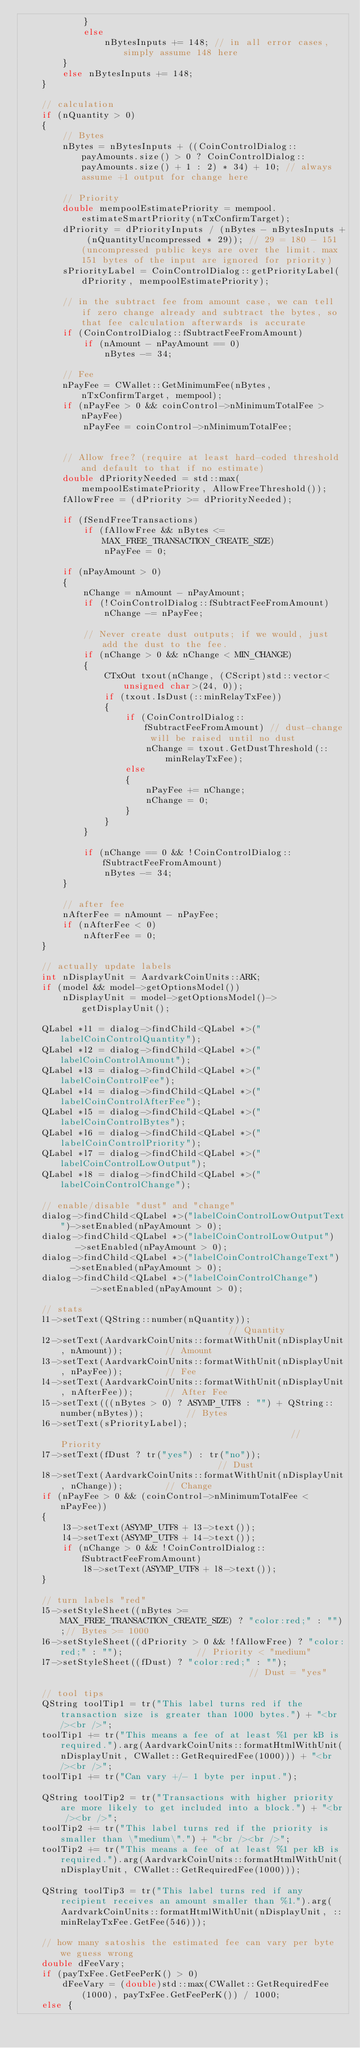<code> <loc_0><loc_0><loc_500><loc_500><_C++_>            }
            else
                nBytesInputs += 148; // in all error cases, simply assume 148 here
        }
        else nBytesInputs += 148;
    }

    // calculation
    if (nQuantity > 0)
    {
        // Bytes
        nBytes = nBytesInputs + ((CoinControlDialog::payAmounts.size() > 0 ? CoinControlDialog::payAmounts.size() + 1 : 2) * 34) + 10; // always assume +1 output for change here

        // Priority
        double mempoolEstimatePriority = mempool.estimateSmartPriority(nTxConfirmTarget);
        dPriority = dPriorityInputs / (nBytes - nBytesInputs + (nQuantityUncompressed * 29)); // 29 = 180 - 151 (uncompressed public keys are over the limit. max 151 bytes of the input are ignored for priority)
        sPriorityLabel = CoinControlDialog::getPriorityLabel(dPriority, mempoolEstimatePriority);

        // in the subtract fee from amount case, we can tell if zero change already and subtract the bytes, so that fee calculation afterwards is accurate
        if (CoinControlDialog::fSubtractFeeFromAmount)
            if (nAmount - nPayAmount == 0)
                nBytes -= 34;

        // Fee
        nPayFee = CWallet::GetMinimumFee(nBytes, nTxConfirmTarget, mempool);
        if (nPayFee > 0 && coinControl->nMinimumTotalFee > nPayFee)
            nPayFee = coinControl->nMinimumTotalFee;


        // Allow free? (require at least hard-coded threshold and default to that if no estimate)
        double dPriorityNeeded = std::max(mempoolEstimatePriority, AllowFreeThreshold());
        fAllowFree = (dPriority >= dPriorityNeeded);

        if (fSendFreeTransactions)
            if (fAllowFree && nBytes <= MAX_FREE_TRANSACTION_CREATE_SIZE)
                nPayFee = 0;

        if (nPayAmount > 0)
        {
            nChange = nAmount - nPayAmount;
            if (!CoinControlDialog::fSubtractFeeFromAmount)
                nChange -= nPayFee;

            // Never create dust outputs; if we would, just add the dust to the fee.
            if (nChange > 0 && nChange < MIN_CHANGE)
            {
                CTxOut txout(nChange, (CScript)std::vector<unsigned char>(24, 0));
                if (txout.IsDust(::minRelayTxFee))
                {
                    if (CoinControlDialog::fSubtractFeeFromAmount) // dust-change will be raised until no dust
                        nChange = txout.GetDustThreshold(::minRelayTxFee);
                    else
                    {
                        nPayFee += nChange;
                        nChange = 0;
                    }
                }
            }

            if (nChange == 0 && !CoinControlDialog::fSubtractFeeFromAmount)
                nBytes -= 34;
        }

        // after fee
        nAfterFee = nAmount - nPayFee;
        if (nAfterFee < 0)
            nAfterFee = 0;
    }

    // actually update labels
    int nDisplayUnit = AardvarkCoinUnits::ARK;
    if (model && model->getOptionsModel())
        nDisplayUnit = model->getOptionsModel()->getDisplayUnit();

    QLabel *l1 = dialog->findChild<QLabel *>("labelCoinControlQuantity");
    QLabel *l2 = dialog->findChild<QLabel *>("labelCoinControlAmount");
    QLabel *l3 = dialog->findChild<QLabel *>("labelCoinControlFee");
    QLabel *l4 = dialog->findChild<QLabel *>("labelCoinControlAfterFee");
    QLabel *l5 = dialog->findChild<QLabel *>("labelCoinControlBytes");
    QLabel *l6 = dialog->findChild<QLabel *>("labelCoinControlPriority");
    QLabel *l7 = dialog->findChild<QLabel *>("labelCoinControlLowOutput");
    QLabel *l8 = dialog->findChild<QLabel *>("labelCoinControlChange");

    // enable/disable "dust" and "change"
    dialog->findChild<QLabel *>("labelCoinControlLowOutputText")->setEnabled(nPayAmount > 0);
    dialog->findChild<QLabel *>("labelCoinControlLowOutput")    ->setEnabled(nPayAmount > 0);
    dialog->findChild<QLabel *>("labelCoinControlChangeText")   ->setEnabled(nPayAmount > 0);
    dialog->findChild<QLabel *>("labelCoinControlChange")       ->setEnabled(nPayAmount > 0);

    // stats
    l1->setText(QString::number(nQuantity));                                 // Quantity
    l2->setText(AardvarkCoinUnits::formatWithUnit(nDisplayUnit, nAmount));        // Amount
    l3->setText(AardvarkCoinUnits::formatWithUnit(nDisplayUnit, nPayFee));        // Fee
    l4->setText(AardvarkCoinUnits::formatWithUnit(nDisplayUnit, nAfterFee));      // After Fee
    l5->setText(((nBytes > 0) ? ASYMP_UTF8 : "") + QString::number(nBytes));        // Bytes
    l6->setText(sPriorityLabel);                                             // Priority
    l7->setText(fDust ? tr("yes") : tr("no"));                               // Dust
    l8->setText(AardvarkCoinUnits::formatWithUnit(nDisplayUnit, nChange));        // Change
    if (nPayFee > 0 && (coinControl->nMinimumTotalFee < nPayFee))
    {
        l3->setText(ASYMP_UTF8 + l3->text());
        l4->setText(ASYMP_UTF8 + l4->text());
        if (nChange > 0 && !CoinControlDialog::fSubtractFeeFromAmount)
            l8->setText(ASYMP_UTF8 + l8->text());
    }

    // turn labels "red"
    l5->setStyleSheet((nBytes >= MAX_FREE_TRANSACTION_CREATE_SIZE) ? "color:red;" : "");// Bytes >= 1000
    l6->setStyleSheet((dPriority > 0 && !fAllowFree) ? "color:red;" : "");              // Priority < "medium"
    l7->setStyleSheet((fDust) ? "color:red;" : "");                                     // Dust = "yes"

    // tool tips
    QString toolTip1 = tr("This label turns red if the transaction size is greater than 1000 bytes.") + "<br /><br />";
    toolTip1 += tr("This means a fee of at least %1 per kB is required.").arg(AardvarkCoinUnits::formatHtmlWithUnit(nDisplayUnit, CWallet::GetRequiredFee(1000))) + "<br /><br />";
    toolTip1 += tr("Can vary +/- 1 byte per input.");

    QString toolTip2 = tr("Transactions with higher priority are more likely to get included into a block.") + "<br /><br />";
    toolTip2 += tr("This label turns red if the priority is smaller than \"medium\".") + "<br /><br />";
    toolTip2 += tr("This means a fee of at least %1 per kB is required.").arg(AardvarkCoinUnits::formatHtmlWithUnit(nDisplayUnit, CWallet::GetRequiredFee(1000)));

    QString toolTip3 = tr("This label turns red if any recipient receives an amount smaller than %1.").arg(AardvarkCoinUnits::formatHtmlWithUnit(nDisplayUnit, ::minRelayTxFee.GetFee(546)));

    // how many satoshis the estimated fee can vary per byte we guess wrong
    double dFeeVary;
    if (payTxFee.GetFeePerK() > 0)
        dFeeVary = (double)std::max(CWallet::GetRequiredFee(1000), payTxFee.GetFeePerK()) / 1000;
    else {</code> 